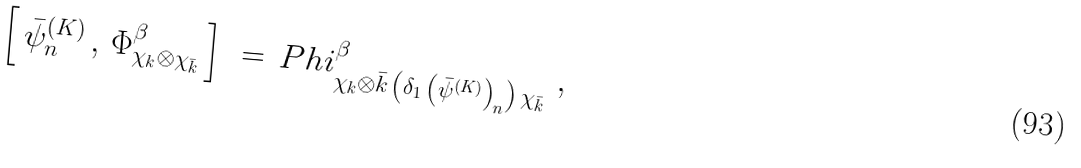<formula> <loc_0><loc_0><loc_500><loc_500>\left [ \, \bar { \psi } _ { n } ^ { ( K ) } \, , \, \Phi _ { \chi _ { k } \otimes \chi _ { \bar { k } } } ^ { \beta } \, \right ] \ = \, P h i _ { \chi _ { k } \otimes \bar { k } \, \left ( \delta _ { 1 } \, \left ( \bar { \psi } ^ { ( K ) } \right ) _ { n } \right ) \, \chi _ { \bar { k } } } ^ { \beta } \ ,</formula> 